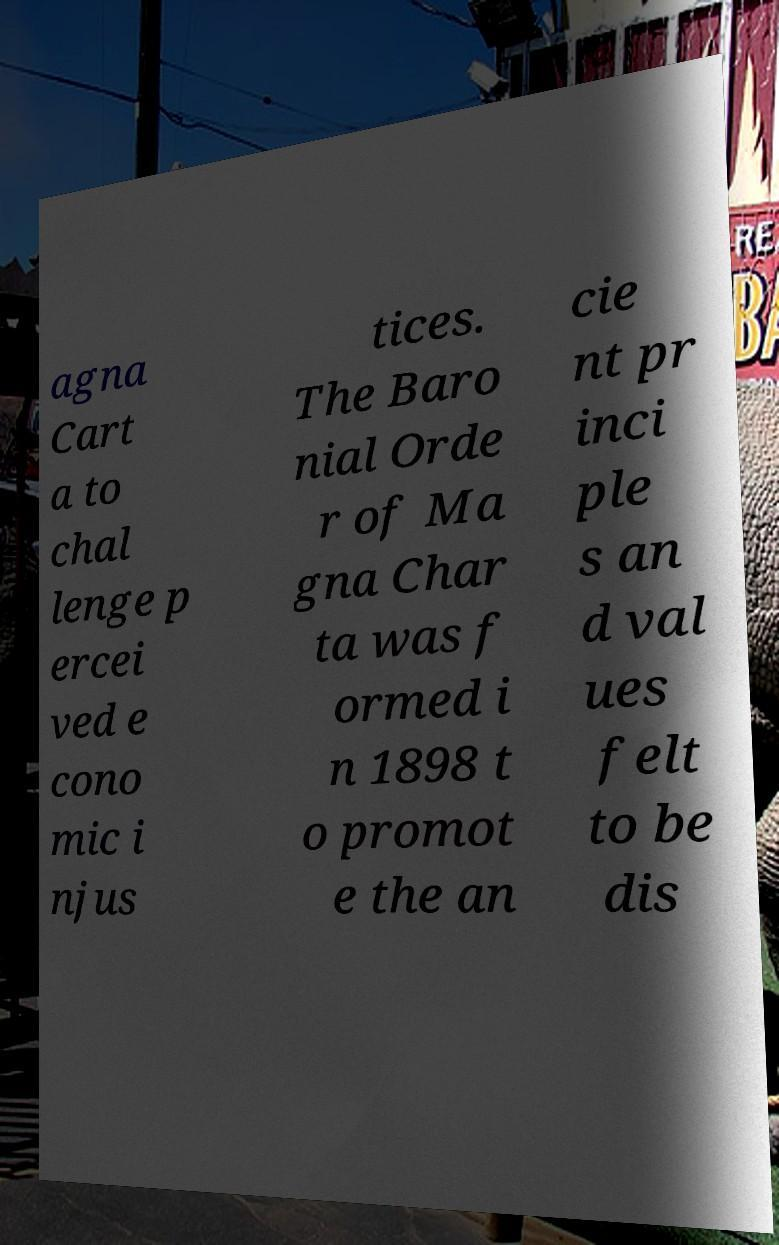Could you extract and type out the text from this image? agna Cart a to chal lenge p ercei ved e cono mic i njus tices. The Baro nial Orde r of Ma gna Char ta was f ormed i n 1898 t o promot e the an cie nt pr inci ple s an d val ues felt to be dis 